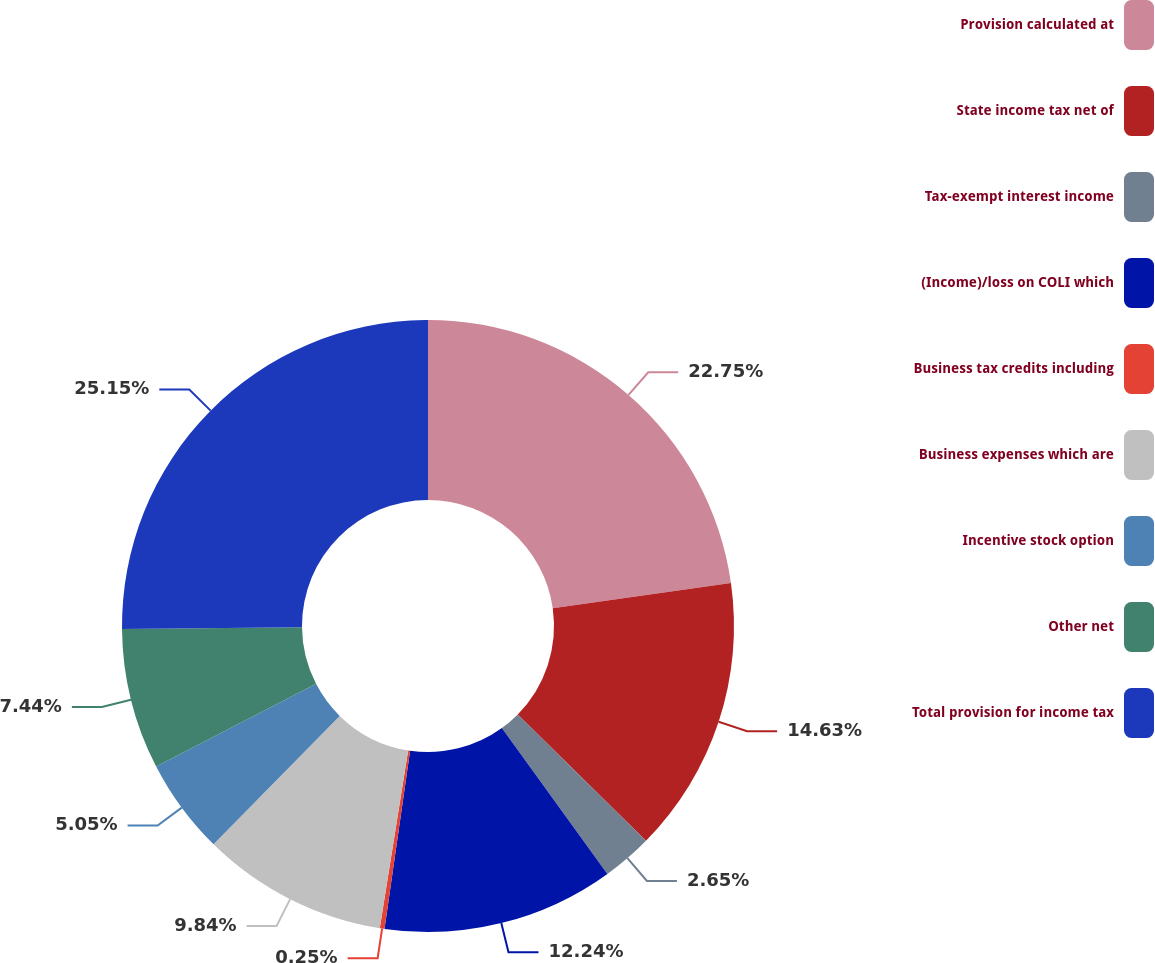<chart> <loc_0><loc_0><loc_500><loc_500><pie_chart><fcel>Provision calculated at<fcel>State income tax net of<fcel>Tax-exempt interest income<fcel>(Income)/loss on COLI which<fcel>Business tax credits including<fcel>Business expenses which are<fcel>Incentive stock option<fcel>Other net<fcel>Total provision for income tax<nl><fcel>22.75%<fcel>14.63%<fcel>2.65%<fcel>12.24%<fcel>0.25%<fcel>9.84%<fcel>5.05%<fcel>7.44%<fcel>25.15%<nl></chart> 